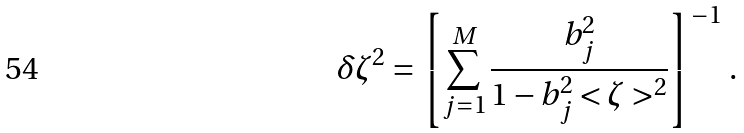Convert formula to latex. <formula><loc_0><loc_0><loc_500><loc_500>\delta \zeta ^ { 2 } = \left [ \sum _ { j = 1 } ^ { M } \frac { b ^ { 2 } _ { j } } { 1 - b ^ { 2 } _ { j } < \zeta > ^ { 2 } } \right ] ^ { - 1 } \, .</formula> 